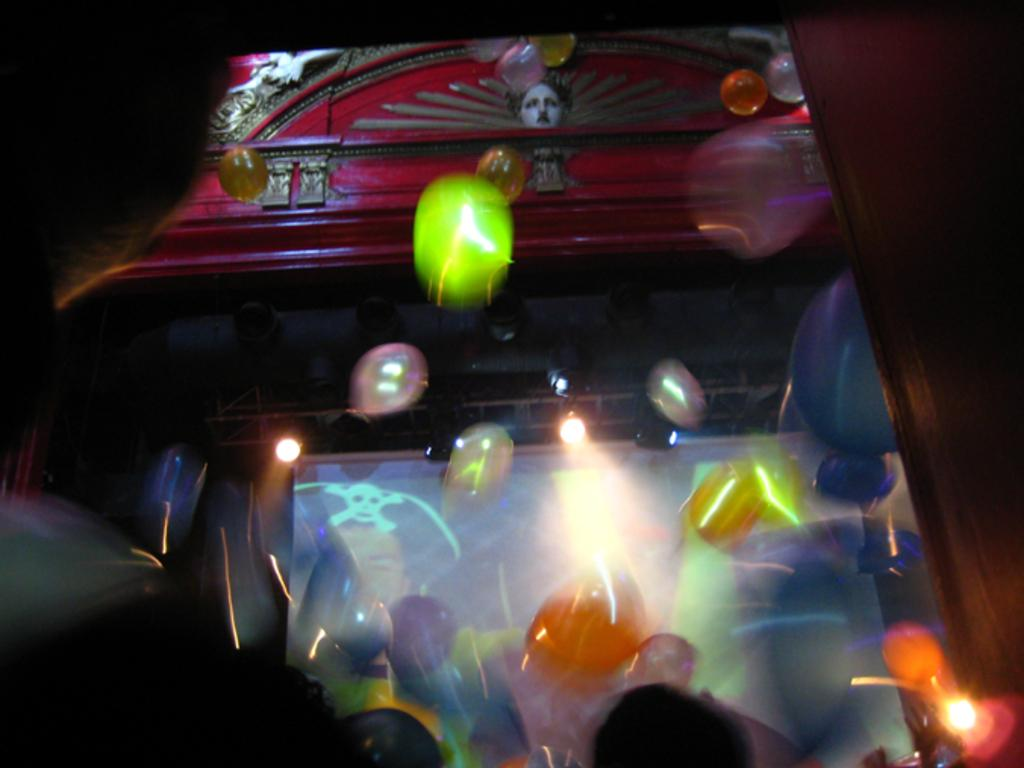What is the main feature of the image? There is a stage in the image. What is on the stage? There is a screen on the stage. Are there any decorations or additional elements in the image? Yes, there are objects in the image that resemble balloons. What is the angle of the home in the image? There is no home present in the image; it features a stage with a screen and balloon-like objects. 